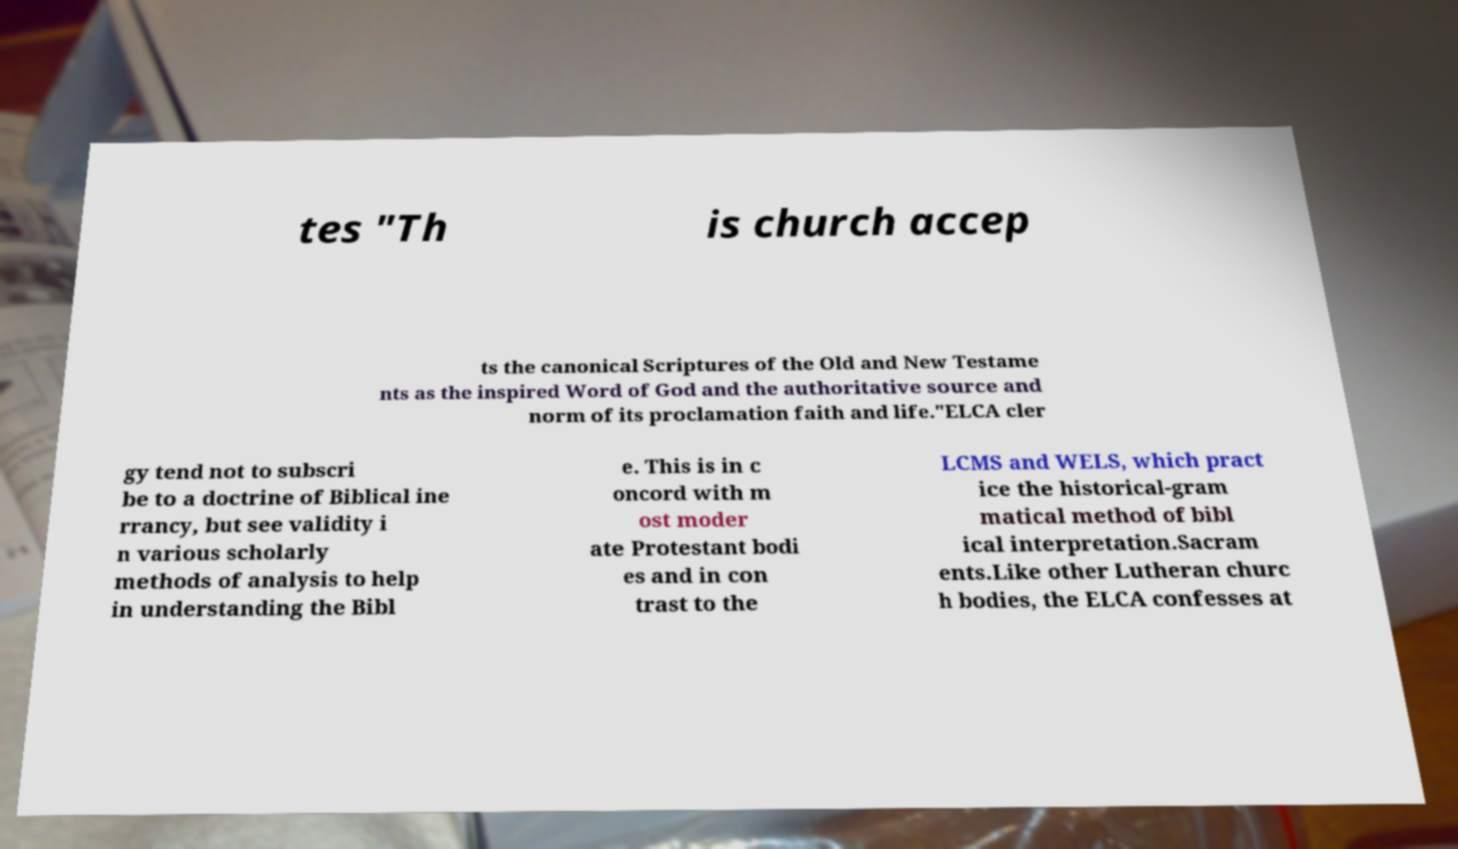What messages or text are displayed in this image? I need them in a readable, typed format. tes "Th is church accep ts the canonical Scriptures of the Old and New Testame nts as the inspired Word of God and the authoritative source and norm of its proclamation faith and life."ELCA cler gy tend not to subscri be to a doctrine of Biblical ine rrancy, but see validity i n various scholarly methods of analysis to help in understanding the Bibl e. This is in c oncord with m ost moder ate Protestant bodi es and in con trast to the LCMS and WELS, which pract ice the historical-gram matical method of bibl ical interpretation.Sacram ents.Like other Lutheran churc h bodies, the ELCA confesses at 